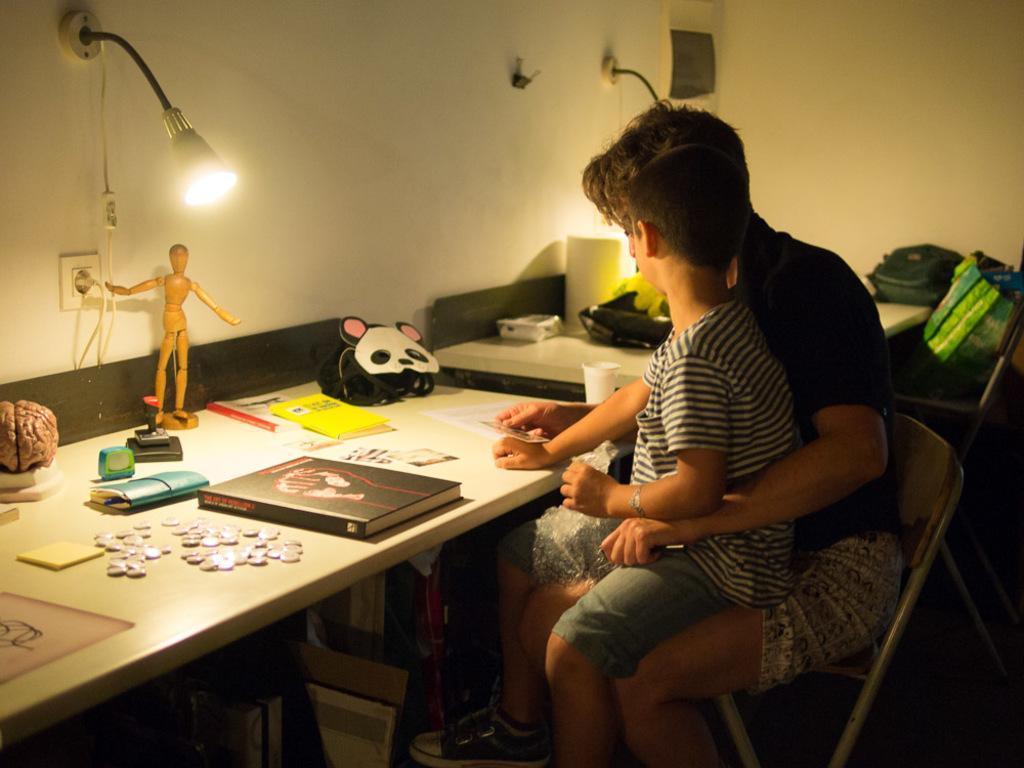Please provide a concise description of this image. In this image we can see a man is sitting, and here a boy is sitting, in front here is the table, books, and some objects on it, at above here is the light, here is the wall. 